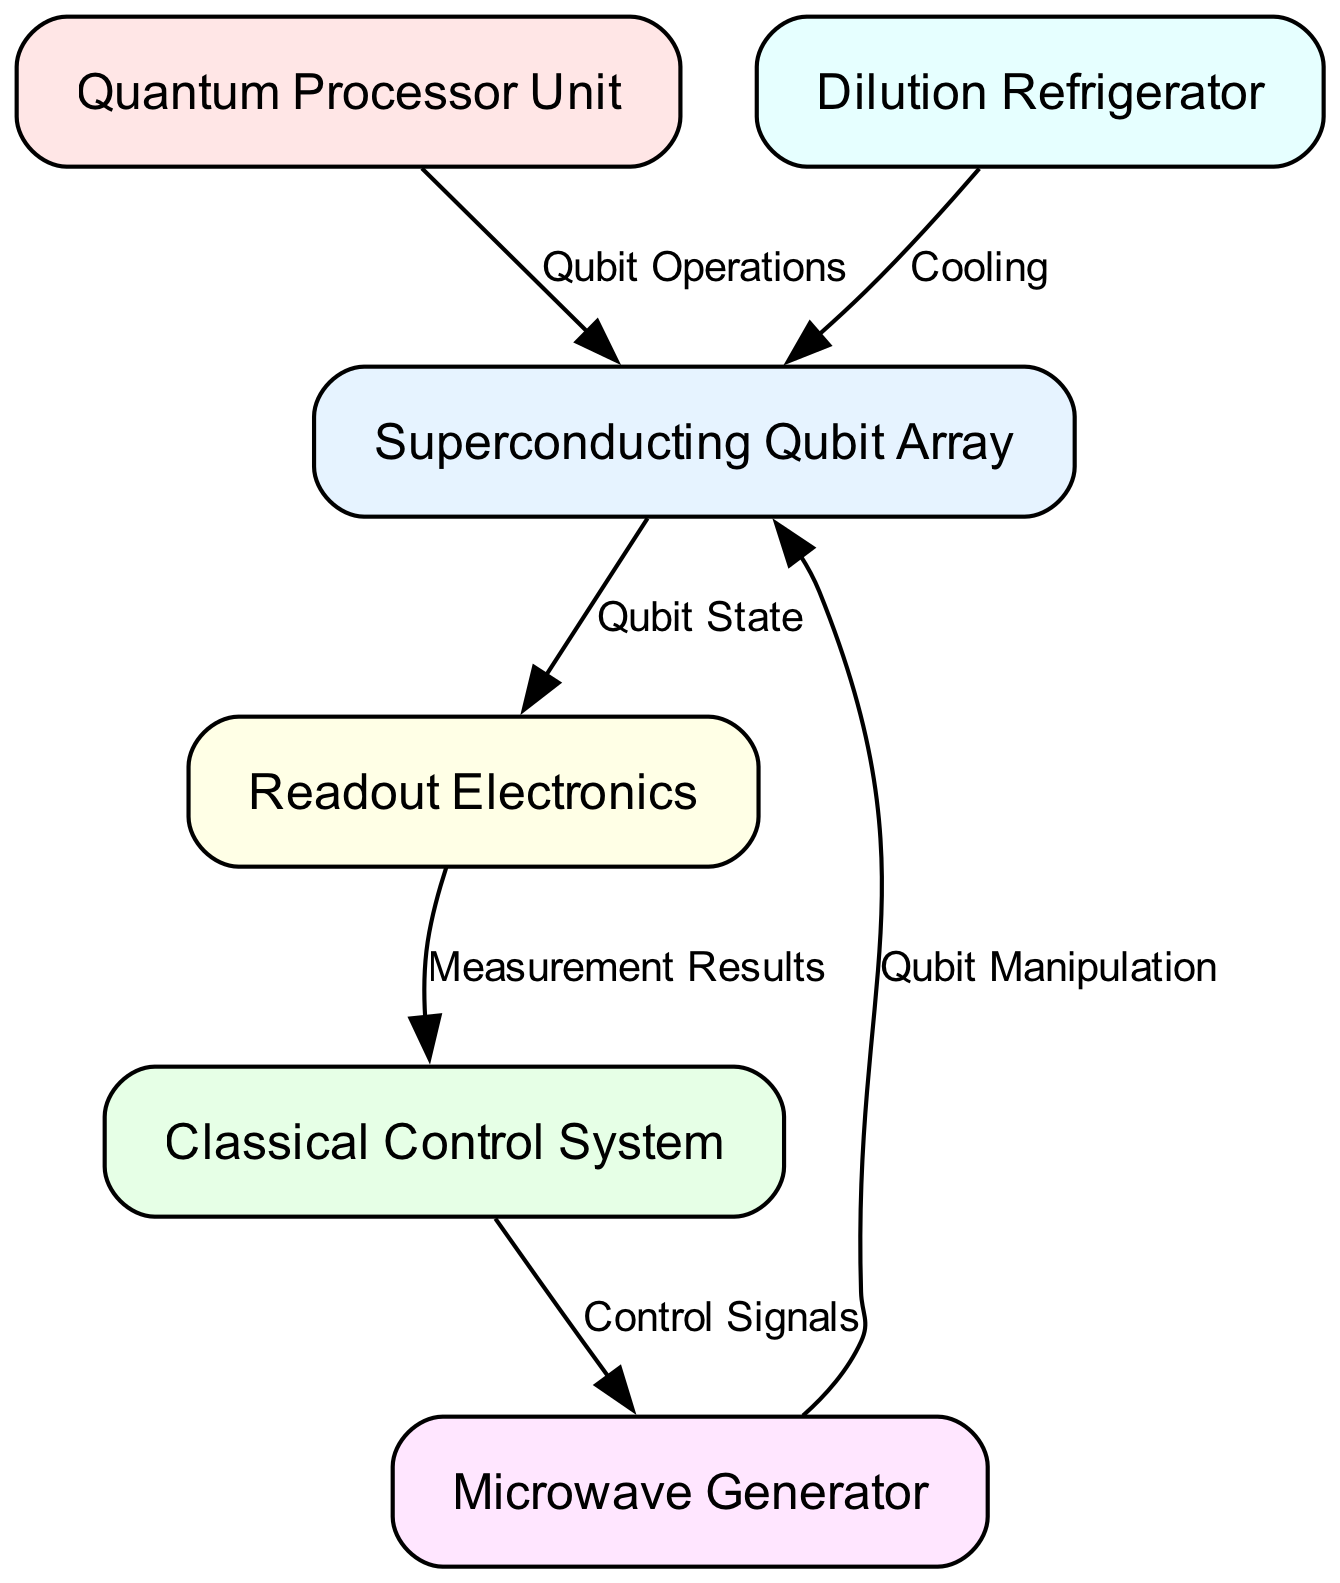What is the label of the first node in the diagram? The first node in the provided data is labeled "Superconducting Qubit Array." This can be found by looking at the first entry in the "nodes" list of the diagram data.
Answer: Superconducting Qubit Array How many nodes are present in the block diagram? By counting the number of entries in the "nodes" list, one can determine that there are 6 nodes in total: Superconducting Qubit Array, Quantum Processor Unit, Classical Control System, Microwave Generator, Readout Electronics, and Dilution Refrigerator.
Answer: 6 What label is associated with the edge from the control system to the microwave generator? The edge connecting the control system to the microwave generator is labeled "Control Signals." This is specified in the "edges" list in the data.
Answer: Control Signals Which node is responsible for qubit manipulation? The "Microwave Generator" node is responsible for qubit manipulation, as indicated by the directed edge labeled "Qubit Manipulation" that originates from the microwave node and leads to the qubit array.
Answer: Microwave Generator What does the readout electronics output to? The readout electronics output to the classical control system, as denoted by the directed edge labeled "Measurement Results" that connects these two nodes.
Answer: Classical Control System Which component is responsible for cooling within the architecture? The "Dilution Refrigerator" node is designated for cooling the superconducting qubit array, as shown by the edge labeled "Cooling" that connects these two nodes.
Answer: Dilution Refrigerator If the quantum processor unit performs operations, which component does it directly interact with? The quantum processor unit directly interacts with the superconducting qubit array to perform operations, as indicated by the edge labeled "Qubit Operations" leading from the quantum processor to the qubit array.
Answer: Superconducting Qubit Array How many edges are present in the block diagram? By counting the listed edges in the "edges" array, there are 6 edges total, capturing the interactions and control relationships between the different nodes described.
Answer: 6 What type of systems does the classical control system manage? The classical control system manages both the microwave generator and the readout electronics, evidenced by the directed edges leading from it to these two nodes, indicating the flow of control signals and measurement results respectively.
Answer: Microwave Generator and Readout Electronics 